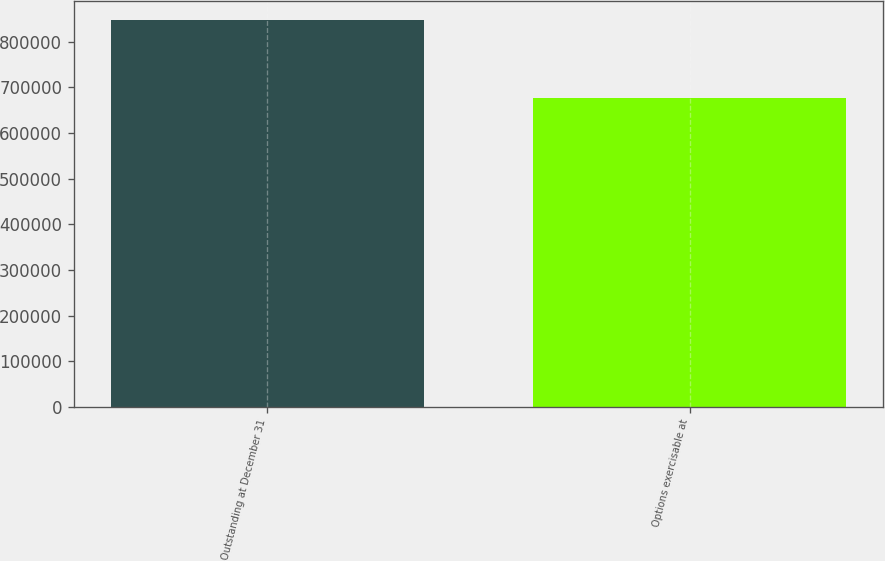<chart> <loc_0><loc_0><loc_500><loc_500><bar_chart><fcel>Outstanding at December 31<fcel>Options exercisable at<nl><fcel>847830<fcel>676202<nl></chart> 